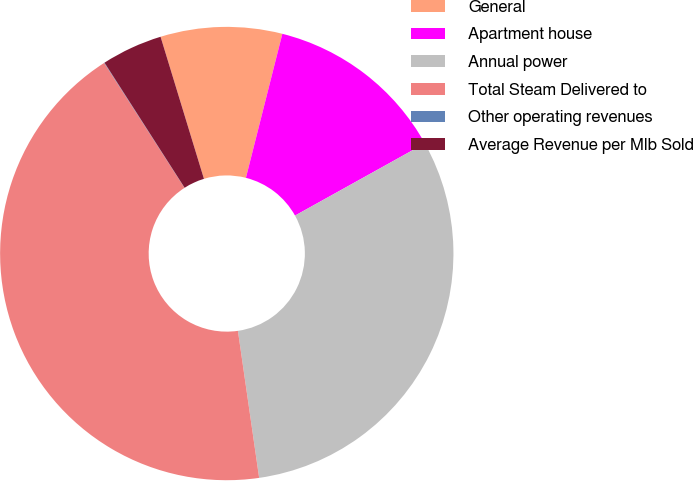Convert chart to OTSL. <chart><loc_0><loc_0><loc_500><loc_500><pie_chart><fcel>General<fcel>Apartment house<fcel>Annual power<fcel>Total Steam Delivered to<fcel>Other operating revenues<fcel>Average Revenue per Mlb Sold<nl><fcel>8.66%<fcel>12.98%<fcel>30.79%<fcel>43.18%<fcel>0.03%<fcel>4.35%<nl></chart> 